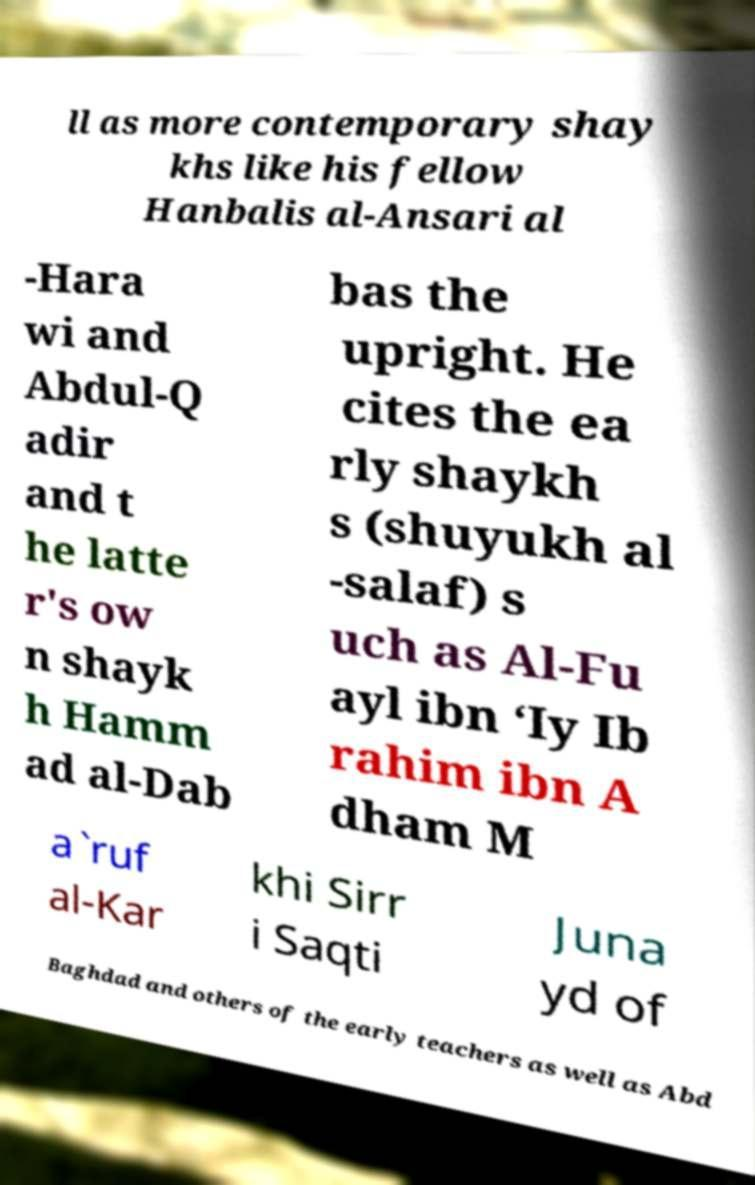I need the written content from this picture converted into text. Can you do that? ll as more contemporary shay khs like his fellow Hanbalis al-Ansari al -Hara wi and Abdul-Q adir and t he latte r's ow n shayk h Hamm ad al-Dab bas the upright. He cites the ea rly shaykh s (shuyukh al -salaf) s uch as Al-Fu ayl ibn ‘Iy Ib rahim ibn A dham M a`ruf al-Kar khi Sirr i Saqti Juna yd of Baghdad and others of the early teachers as well as Abd 